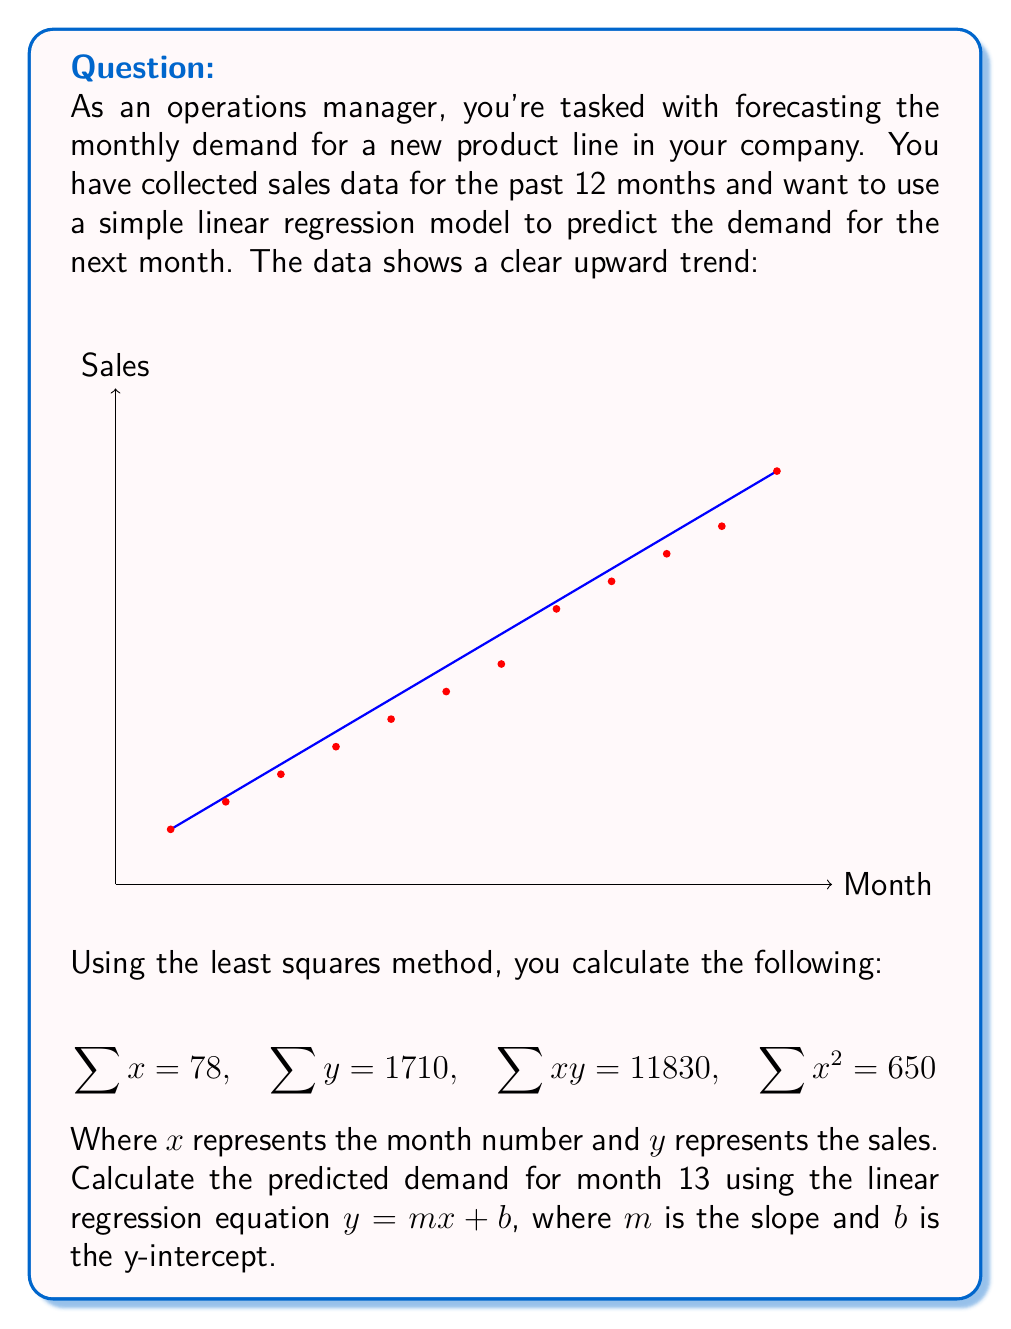Solve this math problem. To solve this problem, we'll follow these steps:

1) First, we need to calculate the slope ($m$) and y-intercept ($b$) of the linear regression line using the least squares method.

2) The formulas for $m$ and $b$ are:

   $$m = \frac{n\sum xy - \sum x \sum y}{n\sum x^2 - (\sum x)^2}$$
   
   $$b = \frac{\sum y - m\sum x}{n}$$

   where $n$ is the number of data points (12 in this case).

3) Let's calculate $m$ first:

   $$m = \frac{12(11830) - 78(1710)}{12(650) - 78^2}$$
   $$= \frac{141960 - 133380}{7800 - 6084}$$
   $$= \frac{8580}{1716}$$
   $$= 5$$

4) Now let's calculate $b$:

   $$b = \frac{1710 - 5(78)}{12}$$
   $$= \frac{1710 - 390}{12}$$
   $$= \frac{1320}{12}$$
   $$= 110$$

5) Our linear regression equation is therefore:

   $$y = 5x + 110$$

6) To predict the demand for month 13, we simply plug in $x = 13$:

   $$y = 5(13) + 110 = 65 + 110 = 175$$

Therefore, the predicted demand for month 13 is 175 units.
Answer: 175 units 